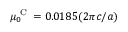Convert formula to latex. <formula><loc_0><loc_0><loc_500><loc_500>\mu _ { 0 } ^ { C } = 0 . 0 1 8 5 ( 2 \pi c / a )</formula> 